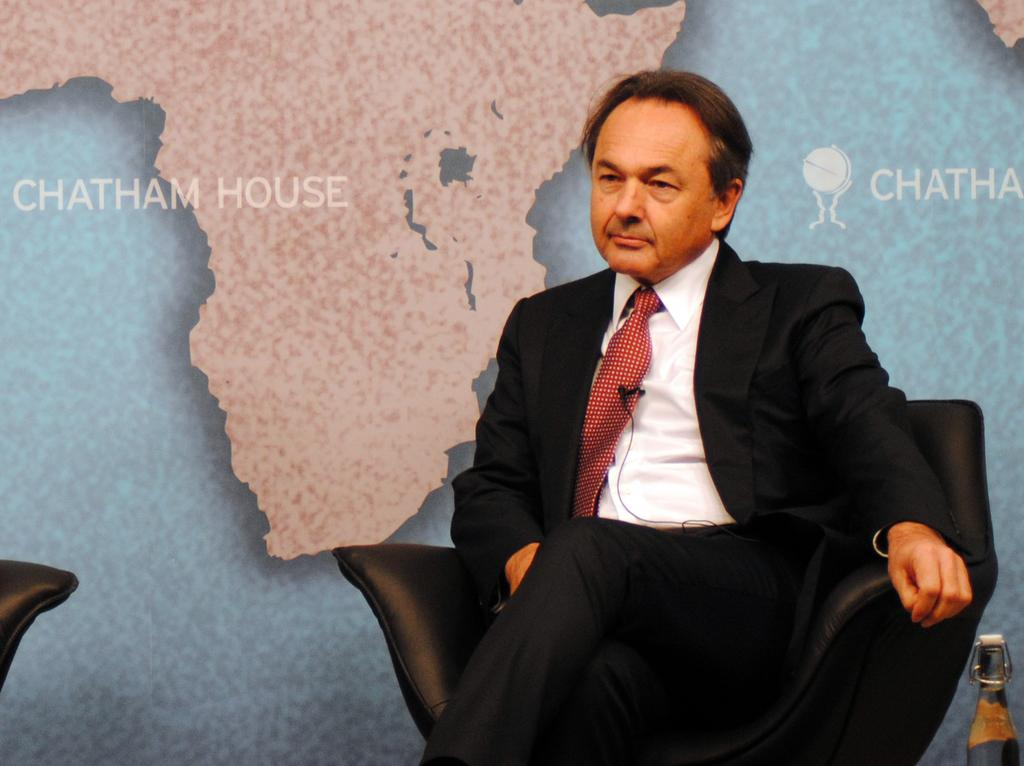What is the man in the image doing? The man is sitting on a chair in the image. What color is the chair the man is sitting on? The chair is black. What type of clothing is the man wearing? The man is wearing a tie, a shirt, and a black suit. What can be seen in the background of the image? There are maps and names written on the wall in the background of the image. What flavor of ice cream does the man prefer, based on the image? There is no information about the man's ice cream preferences in the image. 